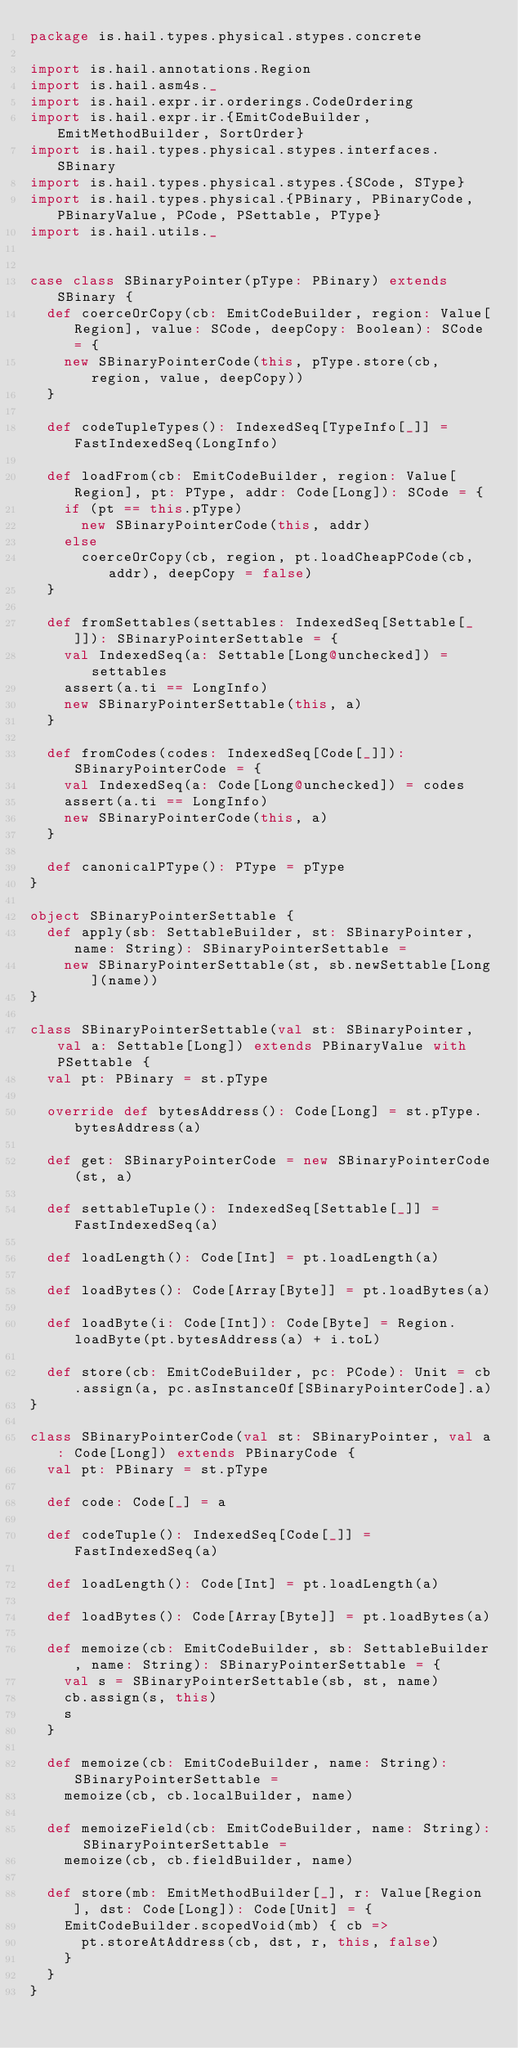Convert code to text. <code><loc_0><loc_0><loc_500><loc_500><_Scala_>package is.hail.types.physical.stypes.concrete

import is.hail.annotations.Region
import is.hail.asm4s._
import is.hail.expr.ir.orderings.CodeOrdering
import is.hail.expr.ir.{EmitCodeBuilder, EmitMethodBuilder, SortOrder}
import is.hail.types.physical.stypes.interfaces.SBinary
import is.hail.types.physical.stypes.{SCode, SType}
import is.hail.types.physical.{PBinary, PBinaryCode, PBinaryValue, PCode, PSettable, PType}
import is.hail.utils._


case class SBinaryPointer(pType: PBinary) extends SBinary {
  def coerceOrCopy(cb: EmitCodeBuilder, region: Value[Region], value: SCode, deepCopy: Boolean): SCode = {
    new SBinaryPointerCode(this, pType.store(cb, region, value, deepCopy))
  }

  def codeTupleTypes(): IndexedSeq[TypeInfo[_]] = FastIndexedSeq(LongInfo)

  def loadFrom(cb: EmitCodeBuilder, region: Value[Region], pt: PType, addr: Code[Long]): SCode = {
    if (pt == this.pType)
      new SBinaryPointerCode(this, addr)
    else
      coerceOrCopy(cb, region, pt.loadCheapPCode(cb, addr), deepCopy = false)
  }

  def fromSettables(settables: IndexedSeq[Settable[_]]): SBinaryPointerSettable = {
    val IndexedSeq(a: Settable[Long@unchecked]) = settables
    assert(a.ti == LongInfo)
    new SBinaryPointerSettable(this, a)
  }

  def fromCodes(codes: IndexedSeq[Code[_]]): SBinaryPointerCode = {
    val IndexedSeq(a: Code[Long@unchecked]) = codes
    assert(a.ti == LongInfo)
    new SBinaryPointerCode(this, a)
  }

  def canonicalPType(): PType = pType
}

object SBinaryPointerSettable {
  def apply(sb: SettableBuilder, st: SBinaryPointer, name: String): SBinaryPointerSettable =
    new SBinaryPointerSettable(st, sb.newSettable[Long](name))
}

class SBinaryPointerSettable(val st: SBinaryPointer, val a: Settable[Long]) extends PBinaryValue with PSettable {
  val pt: PBinary = st.pType

  override def bytesAddress(): Code[Long] = st.pType.bytesAddress(a)

  def get: SBinaryPointerCode = new SBinaryPointerCode(st, a)

  def settableTuple(): IndexedSeq[Settable[_]] = FastIndexedSeq(a)

  def loadLength(): Code[Int] = pt.loadLength(a)

  def loadBytes(): Code[Array[Byte]] = pt.loadBytes(a)

  def loadByte(i: Code[Int]): Code[Byte] = Region.loadByte(pt.bytesAddress(a) + i.toL)

  def store(cb: EmitCodeBuilder, pc: PCode): Unit = cb.assign(a, pc.asInstanceOf[SBinaryPointerCode].a)
}

class SBinaryPointerCode(val st: SBinaryPointer, val a: Code[Long]) extends PBinaryCode {
  val pt: PBinary = st.pType

  def code: Code[_] = a

  def codeTuple(): IndexedSeq[Code[_]] = FastIndexedSeq(a)

  def loadLength(): Code[Int] = pt.loadLength(a)

  def loadBytes(): Code[Array[Byte]] = pt.loadBytes(a)

  def memoize(cb: EmitCodeBuilder, sb: SettableBuilder, name: String): SBinaryPointerSettable = {
    val s = SBinaryPointerSettable(sb, st, name)
    cb.assign(s, this)
    s
  }

  def memoize(cb: EmitCodeBuilder, name: String): SBinaryPointerSettable =
    memoize(cb, cb.localBuilder, name)

  def memoizeField(cb: EmitCodeBuilder, name: String): SBinaryPointerSettable =
    memoize(cb, cb.fieldBuilder, name)

  def store(mb: EmitMethodBuilder[_], r: Value[Region], dst: Code[Long]): Code[Unit] = {
    EmitCodeBuilder.scopedVoid(mb) { cb =>
      pt.storeAtAddress(cb, dst, r, this, false)
    }
  }
}
</code> 